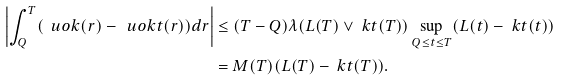Convert formula to latex. <formula><loc_0><loc_0><loc_500><loc_500>\left | \int _ { Q } ^ { T } ( \ u o k ( r ) - \ u o k t ( r ) ) d r \right | & \leq ( T - Q ) \lambda ( L ( T ) \vee \ k t ( T ) ) \sup _ { Q \leq t \leq T } ( L ( t ) - \ k t ( t ) ) \\ & = M ( T ) ( L ( T ) - \ k t ( T ) ) .</formula> 